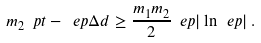<formula> <loc_0><loc_0><loc_500><loc_500>m _ { 2 } \ p t - \ e p \Delta d \geq \frac { m _ { 1 } m _ { 2 } } 2 \ e p | \ln \ e p | \, .</formula> 